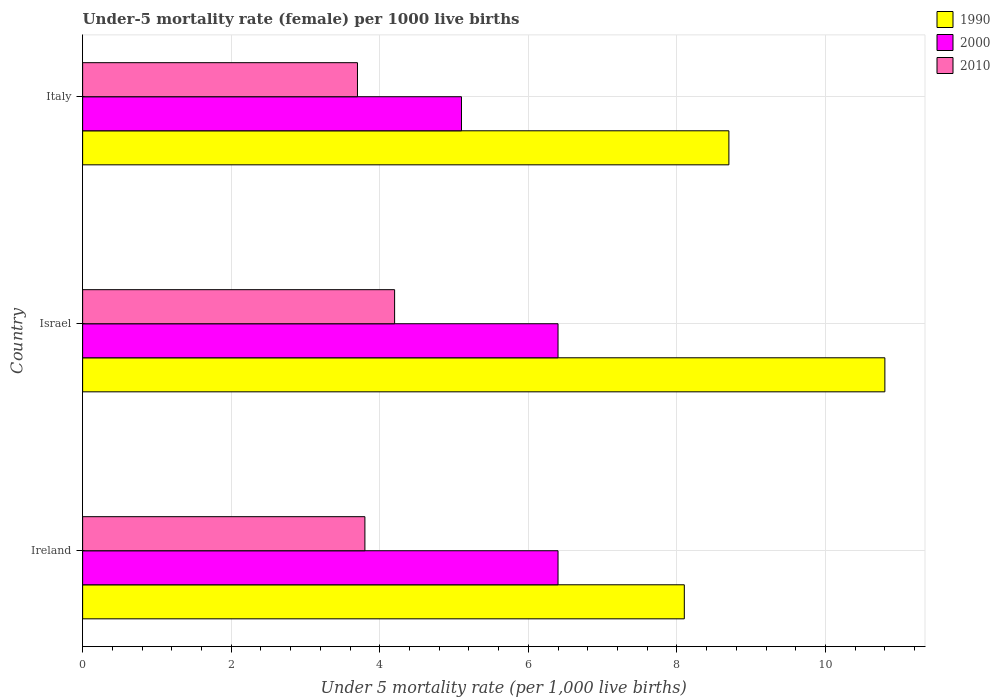How many groups of bars are there?
Your answer should be compact. 3. How many bars are there on the 1st tick from the top?
Your answer should be very brief. 3. How many bars are there on the 1st tick from the bottom?
Give a very brief answer. 3. In how many cases, is the number of bars for a given country not equal to the number of legend labels?
Your answer should be compact. 0. What is the under-five mortality rate in 1990 in Italy?
Offer a terse response. 8.7. Across all countries, what is the maximum under-five mortality rate in 1990?
Provide a succinct answer. 10.8. Across all countries, what is the minimum under-five mortality rate in 1990?
Your response must be concise. 8.1. In which country was the under-five mortality rate in 2000 minimum?
Make the answer very short. Italy. What is the total under-five mortality rate in 1990 in the graph?
Keep it short and to the point. 27.6. What is the difference between the under-five mortality rate in 2000 in Israel and that in Italy?
Your answer should be compact. 1.3. What is the difference between the under-five mortality rate in 2000 in Israel and the under-five mortality rate in 2010 in Ireland?
Offer a terse response. 2.6. What is the average under-five mortality rate in 2000 per country?
Your answer should be compact. 5.97. What is the difference between the under-five mortality rate in 2010 and under-five mortality rate in 1990 in Israel?
Your response must be concise. -6.6. What is the ratio of the under-five mortality rate in 1990 in Ireland to that in Israel?
Keep it short and to the point. 0.75. Is the under-five mortality rate in 2010 in Israel less than that in Italy?
Offer a terse response. No. Is the difference between the under-five mortality rate in 2010 in Ireland and Italy greater than the difference between the under-five mortality rate in 1990 in Ireland and Italy?
Give a very brief answer. Yes. What is the difference between the highest and the second highest under-five mortality rate in 2010?
Your response must be concise. 0.4. What is the difference between the highest and the lowest under-five mortality rate in 2000?
Provide a short and direct response. 1.3. In how many countries, is the under-five mortality rate in 2000 greater than the average under-five mortality rate in 2000 taken over all countries?
Provide a succinct answer. 2. Is the sum of the under-five mortality rate in 2010 in Israel and Italy greater than the maximum under-five mortality rate in 1990 across all countries?
Ensure brevity in your answer.  No. What does the 3rd bar from the top in Italy represents?
Give a very brief answer. 1990. How many bars are there?
Ensure brevity in your answer.  9. Are the values on the major ticks of X-axis written in scientific E-notation?
Give a very brief answer. No. Does the graph contain grids?
Offer a very short reply. Yes. How many legend labels are there?
Your answer should be very brief. 3. How are the legend labels stacked?
Ensure brevity in your answer.  Vertical. What is the title of the graph?
Offer a very short reply. Under-5 mortality rate (female) per 1000 live births. Does "1982" appear as one of the legend labels in the graph?
Offer a very short reply. No. What is the label or title of the X-axis?
Provide a short and direct response. Under 5 mortality rate (per 1,0 live births). What is the label or title of the Y-axis?
Your response must be concise. Country. What is the Under 5 mortality rate (per 1,000 live births) in 2010 in Ireland?
Your answer should be compact. 3.8. What is the Under 5 mortality rate (per 1,000 live births) of 1990 in Israel?
Provide a short and direct response. 10.8. What is the Under 5 mortality rate (per 1,000 live births) in 1990 in Italy?
Ensure brevity in your answer.  8.7. What is the Under 5 mortality rate (per 1,000 live births) in 2010 in Italy?
Provide a succinct answer. 3.7. Across all countries, what is the maximum Under 5 mortality rate (per 1,000 live births) in 2000?
Make the answer very short. 6.4. Across all countries, what is the maximum Under 5 mortality rate (per 1,000 live births) of 2010?
Offer a very short reply. 4.2. Across all countries, what is the minimum Under 5 mortality rate (per 1,000 live births) of 2000?
Your response must be concise. 5.1. Across all countries, what is the minimum Under 5 mortality rate (per 1,000 live births) in 2010?
Keep it short and to the point. 3.7. What is the total Under 5 mortality rate (per 1,000 live births) of 1990 in the graph?
Your answer should be compact. 27.6. What is the difference between the Under 5 mortality rate (per 1,000 live births) in 2000 in Ireland and that in Israel?
Your answer should be very brief. 0. What is the difference between the Under 5 mortality rate (per 1,000 live births) in 2010 in Ireland and that in Israel?
Your answer should be compact. -0.4. What is the difference between the Under 5 mortality rate (per 1,000 live births) of 2000 in Ireland and that in Italy?
Provide a succinct answer. 1.3. What is the difference between the Under 5 mortality rate (per 1,000 live births) in 2010 in Ireland and that in Italy?
Ensure brevity in your answer.  0.1. What is the difference between the Under 5 mortality rate (per 1,000 live births) of 1990 in Israel and that in Italy?
Keep it short and to the point. 2.1. What is the difference between the Under 5 mortality rate (per 1,000 live births) of 2010 in Israel and that in Italy?
Keep it short and to the point. 0.5. What is the difference between the Under 5 mortality rate (per 1,000 live births) of 1990 in Ireland and the Under 5 mortality rate (per 1,000 live births) of 2000 in Israel?
Offer a terse response. 1.7. What is the difference between the Under 5 mortality rate (per 1,000 live births) of 1990 in Ireland and the Under 5 mortality rate (per 1,000 live births) of 2010 in Israel?
Offer a terse response. 3.9. What is the difference between the Under 5 mortality rate (per 1,000 live births) of 1990 in Israel and the Under 5 mortality rate (per 1,000 live births) of 2000 in Italy?
Your answer should be compact. 5.7. What is the difference between the Under 5 mortality rate (per 1,000 live births) of 2000 in Israel and the Under 5 mortality rate (per 1,000 live births) of 2010 in Italy?
Provide a short and direct response. 2.7. What is the average Under 5 mortality rate (per 1,000 live births) of 1990 per country?
Provide a succinct answer. 9.2. What is the average Under 5 mortality rate (per 1,000 live births) in 2000 per country?
Your answer should be compact. 5.97. What is the difference between the Under 5 mortality rate (per 1,000 live births) of 2000 and Under 5 mortality rate (per 1,000 live births) of 2010 in Ireland?
Your answer should be very brief. 2.6. What is the difference between the Under 5 mortality rate (per 1,000 live births) of 2000 and Under 5 mortality rate (per 1,000 live births) of 2010 in Israel?
Your answer should be compact. 2.2. What is the difference between the Under 5 mortality rate (per 1,000 live births) of 1990 and Under 5 mortality rate (per 1,000 live births) of 2000 in Italy?
Offer a very short reply. 3.6. What is the difference between the Under 5 mortality rate (per 1,000 live births) in 1990 and Under 5 mortality rate (per 1,000 live births) in 2010 in Italy?
Provide a succinct answer. 5. What is the difference between the Under 5 mortality rate (per 1,000 live births) of 2000 and Under 5 mortality rate (per 1,000 live births) of 2010 in Italy?
Your response must be concise. 1.4. What is the ratio of the Under 5 mortality rate (per 1,000 live births) of 1990 in Ireland to that in Israel?
Keep it short and to the point. 0.75. What is the ratio of the Under 5 mortality rate (per 1,000 live births) of 2000 in Ireland to that in Israel?
Keep it short and to the point. 1. What is the ratio of the Under 5 mortality rate (per 1,000 live births) of 2010 in Ireland to that in Israel?
Your answer should be compact. 0.9. What is the ratio of the Under 5 mortality rate (per 1,000 live births) of 2000 in Ireland to that in Italy?
Offer a terse response. 1.25. What is the ratio of the Under 5 mortality rate (per 1,000 live births) in 1990 in Israel to that in Italy?
Give a very brief answer. 1.24. What is the ratio of the Under 5 mortality rate (per 1,000 live births) in 2000 in Israel to that in Italy?
Your answer should be compact. 1.25. What is the ratio of the Under 5 mortality rate (per 1,000 live births) in 2010 in Israel to that in Italy?
Provide a succinct answer. 1.14. What is the difference between the highest and the second highest Under 5 mortality rate (per 1,000 live births) in 1990?
Your response must be concise. 2.1. What is the difference between the highest and the second highest Under 5 mortality rate (per 1,000 live births) in 2010?
Ensure brevity in your answer.  0.4. What is the difference between the highest and the lowest Under 5 mortality rate (per 1,000 live births) in 2000?
Make the answer very short. 1.3. What is the difference between the highest and the lowest Under 5 mortality rate (per 1,000 live births) in 2010?
Ensure brevity in your answer.  0.5. 